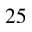Convert formula to latex. <formula><loc_0><loc_0><loc_500><loc_500>2 5</formula> 